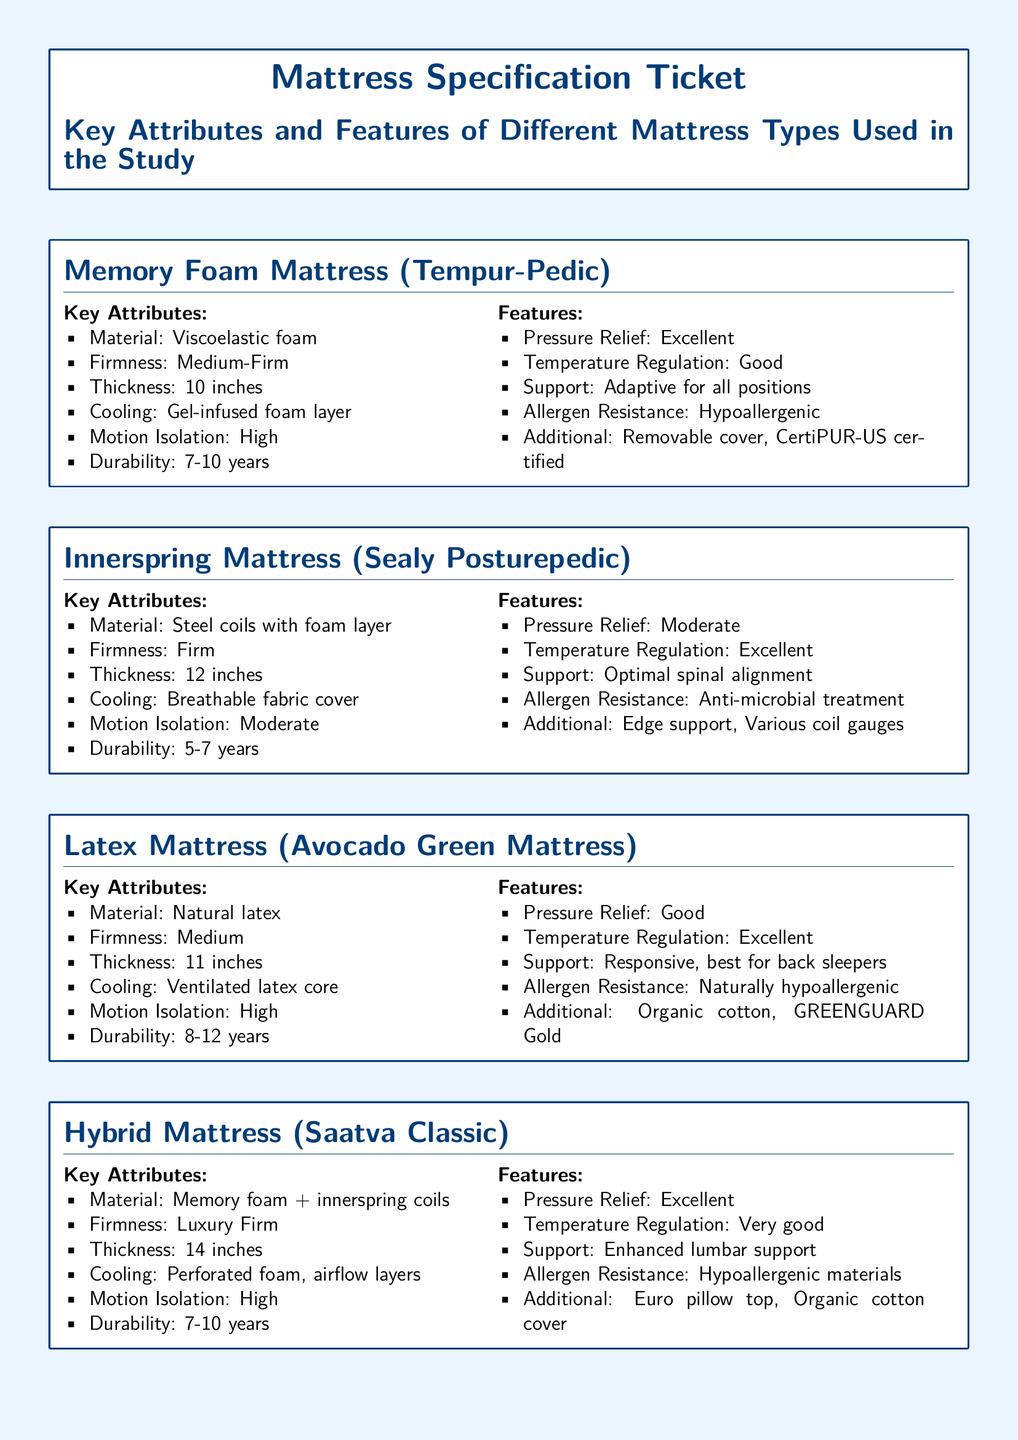what is the firmness of the Memory Foam Mattress? The firmness of the Memory Foam Mattress is specified as Medium-Firm in the document.
Answer: Medium-Firm how thick is the Innerspring Mattress? The thickness of the Innerspring Mattress is stated to be 12 inches.
Answer: 12 inches what is the material of the Hybrid Mattress? The document specifies that the Hybrid Mattress is made from Memory foam + innerspring coils.
Answer: Memory foam + innerspring coils which mattress has the highest durability? The Latex Mattress has a durability of 8-12 years, which is the highest compared to others listed.
Answer: 8-12 years what feature is listed for the Innerspring Mattress regarding allergen resistance? The Innerspring Mattress features an Anti-microbial treatment for allergen resistance.
Answer: Anti-microbial treatment which mattress is specifically noted for its temperature regulation being "very good"? The Hybrid Mattress is noted to have temperature regulation that is "very good."
Answer: very good what is the cooling feature of the Latex Mattress? The cooling feature of the Latex Mattress is described as a Ventilated latex core.
Answer: Ventilated latex core which mattress type is described as best for back sleepers? The Latex Mattress is indicated as responsive and best for back sleepers.
Answer: best for back sleepers what is an additional feature of the Memory Foam Mattress? An additional feature listed for the Memory Foam Mattress is that it is CertiPUR-US certified.
Answer: CertiPUR-US certified 